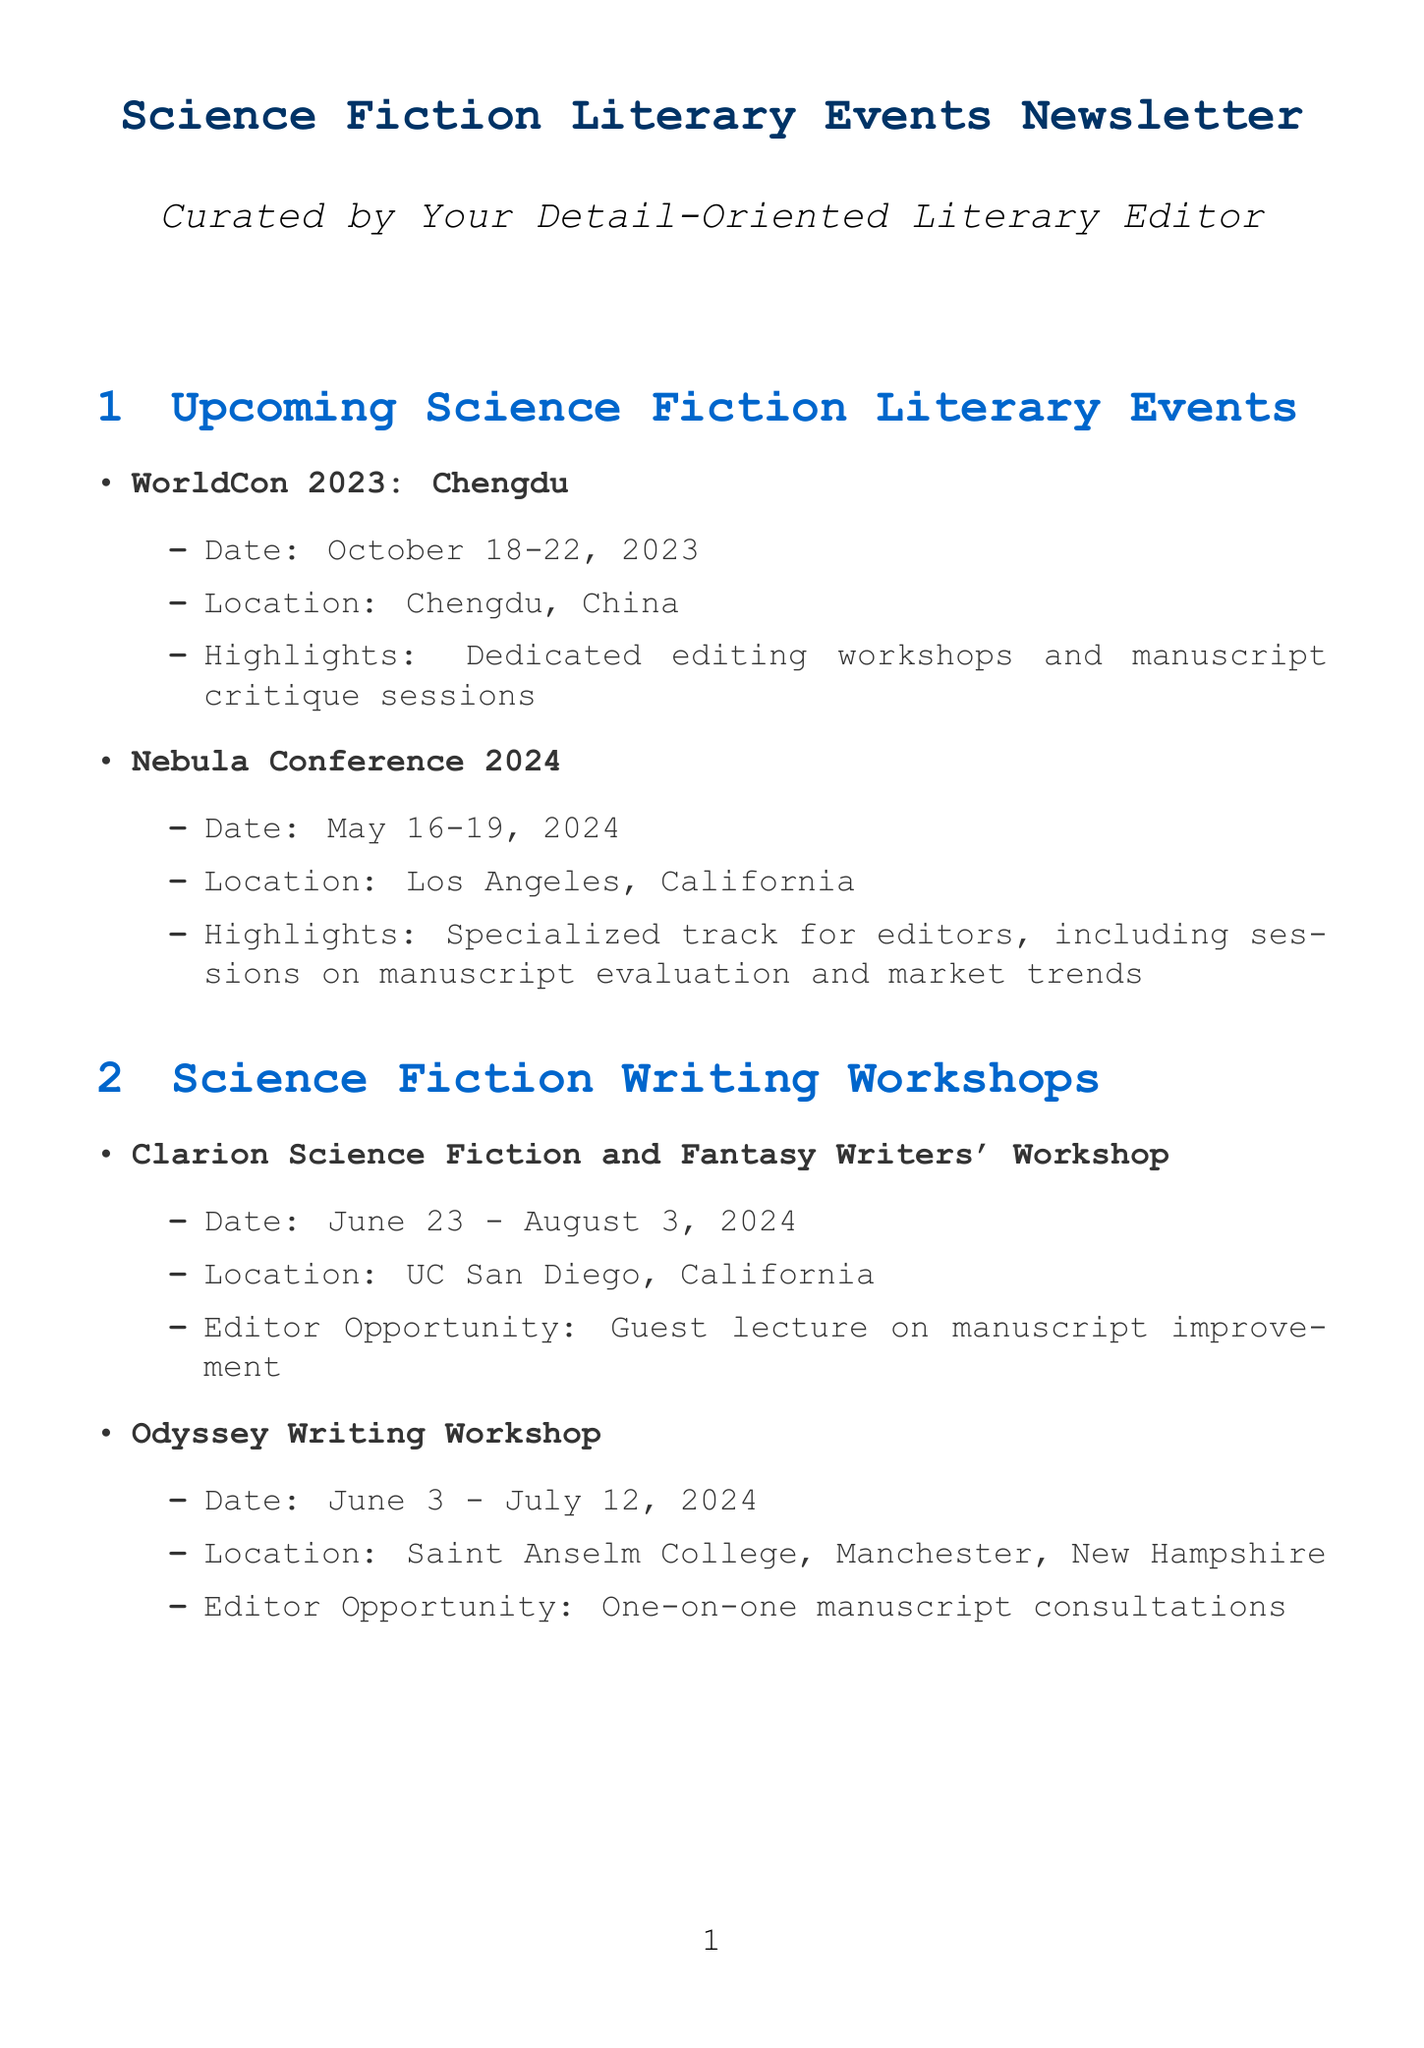What is the date of the WorldCon 2023 event? The date for WorldCon 2023 is specifically mentioned in the document as October 18-22, 2023.
Answer: October 18-22, 2023 Where will the Nebula Conference 2024 take place? The location for the Nebula Conference 2024 is provided in the document as Los Angeles, California.
Answer: Los Angeles, California What is one focus area for the Dragon Con convention? The document states that Dragon Con includes panel discussions on editorial best practices as a focus area.
Answer: Editorial best practices When does the SFWA Editor-Author Virtual Mixer occur next? The document specifies that the next SFWA Editor-Author Virtual Mixer is on September 15, 2023.
Answer: September 15, 2023 What type of editor opportunity is available at the Clarion Science Fiction and Fantasy Writers' Workshop? The document mentions guest lectures on manuscript improvement as the specific opportunity for editors at this workshop.
Answer: Guest lecture on manuscript improvement What is the primary focus of the London Book Fair for editors? The document highlights seminars on emerging trends in science fiction editing as the main focus for editors at the London Book Fair.
Answer: Emerging trends in science fiction editing How long is the Odyssey Writing Workshop? The document notes that the Odyssey Writing Workshop lasts six weeks.
Answer: Six weeks What platform is used for the Science Fiction Editing Webinar Series? According to the document, the platform for the Science Fiction Editing Webinar Series is stated as WebEx.
Answer: WebEx 